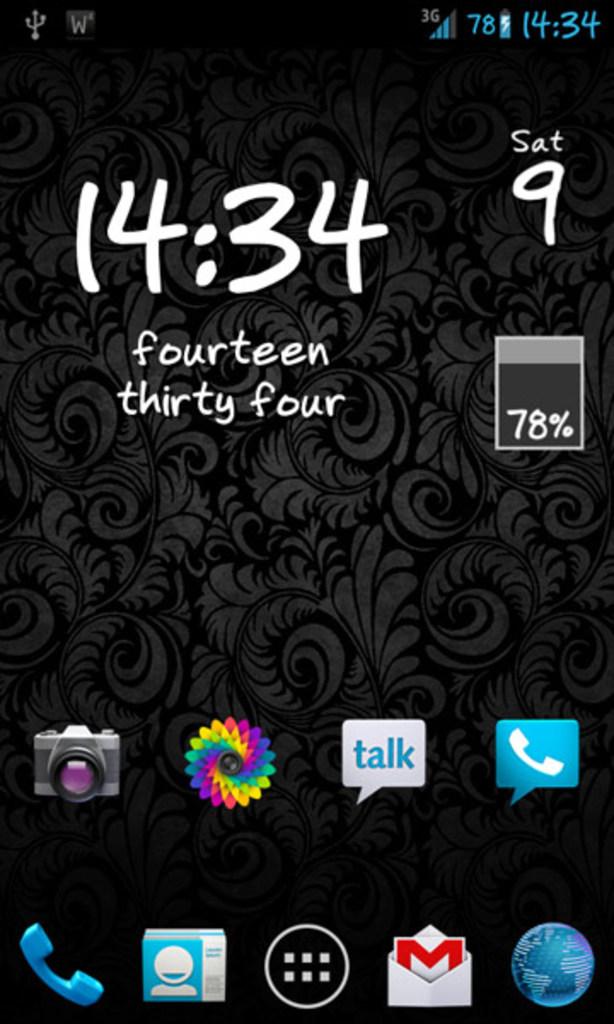What day of the week is it?
Provide a short and direct response. Saturday. 